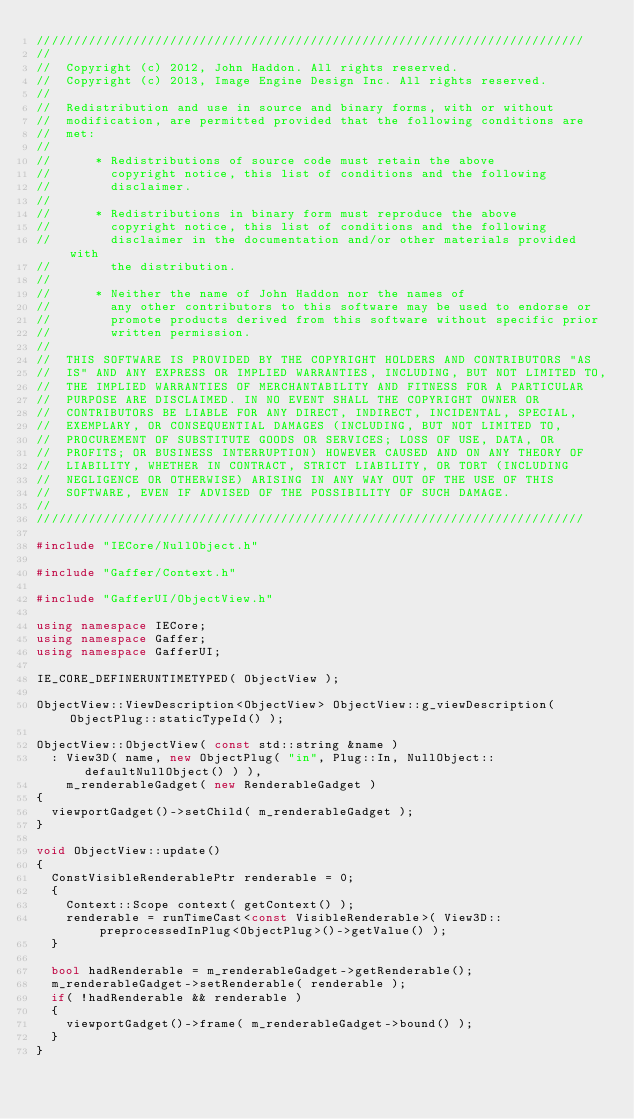<code> <loc_0><loc_0><loc_500><loc_500><_C++_>//////////////////////////////////////////////////////////////////////////
//  
//  Copyright (c) 2012, John Haddon. All rights reserved.
//  Copyright (c) 2013, Image Engine Design Inc. All rights reserved.
//  
//  Redistribution and use in source and binary forms, with or without
//  modification, are permitted provided that the following conditions are
//  met:
//  
//      * Redistributions of source code must retain the above
//        copyright notice, this list of conditions and the following
//        disclaimer.
//  
//      * Redistributions in binary form must reproduce the above
//        copyright notice, this list of conditions and the following
//        disclaimer in the documentation and/or other materials provided with
//        the distribution.
//  
//      * Neither the name of John Haddon nor the names of
//        any other contributors to this software may be used to endorse or
//        promote products derived from this software without specific prior
//        written permission.
//  
//  THIS SOFTWARE IS PROVIDED BY THE COPYRIGHT HOLDERS AND CONTRIBUTORS "AS
//  IS" AND ANY EXPRESS OR IMPLIED WARRANTIES, INCLUDING, BUT NOT LIMITED TO,
//  THE IMPLIED WARRANTIES OF MERCHANTABILITY AND FITNESS FOR A PARTICULAR
//  PURPOSE ARE DISCLAIMED. IN NO EVENT SHALL THE COPYRIGHT OWNER OR
//  CONTRIBUTORS BE LIABLE FOR ANY DIRECT, INDIRECT, INCIDENTAL, SPECIAL,
//  EXEMPLARY, OR CONSEQUENTIAL DAMAGES (INCLUDING, BUT NOT LIMITED TO,
//  PROCUREMENT OF SUBSTITUTE GOODS OR SERVICES; LOSS OF USE, DATA, OR
//  PROFITS; OR BUSINESS INTERRUPTION) HOWEVER CAUSED AND ON ANY THEORY OF
//  LIABILITY, WHETHER IN CONTRACT, STRICT LIABILITY, OR TORT (INCLUDING
//  NEGLIGENCE OR OTHERWISE) ARISING IN ANY WAY OUT OF THE USE OF THIS
//  SOFTWARE, EVEN IF ADVISED OF THE POSSIBILITY OF SUCH DAMAGE.
//  
//////////////////////////////////////////////////////////////////////////

#include "IECore/NullObject.h"

#include "Gaffer/Context.h"

#include "GafferUI/ObjectView.h"

using namespace IECore;
using namespace Gaffer;
using namespace GafferUI;

IE_CORE_DEFINERUNTIMETYPED( ObjectView );

ObjectView::ViewDescription<ObjectView> ObjectView::g_viewDescription( ObjectPlug::staticTypeId() );

ObjectView::ObjectView( const std::string &name )
	:	View3D( name, new ObjectPlug( "in", Plug::In, NullObject::defaultNullObject() ) ),
		m_renderableGadget( new RenderableGadget )
{
	viewportGadget()->setChild( m_renderableGadget );
}

void ObjectView::update()
{
	ConstVisibleRenderablePtr renderable = 0;
	{
		Context::Scope context( getContext() );
		renderable = runTimeCast<const VisibleRenderable>( View3D::preprocessedInPlug<ObjectPlug>()->getValue() );
	}

	bool hadRenderable = m_renderableGadget->getRenderable();
	m_renderableGadget->setRenderable( renderable );
	if( !hadRenderable && renderable )
	{
		viewportGadget()->frame( m_renderableGadget->bound() );
	}
}
</code> 